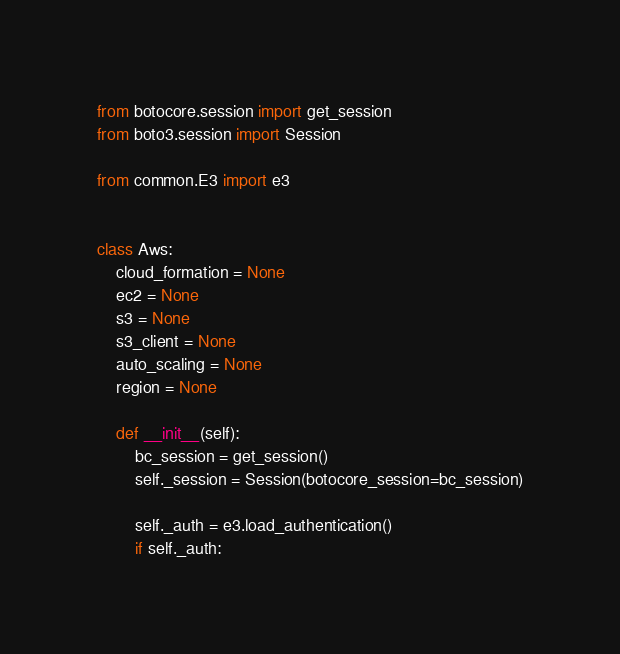Convert code to text. <code><loc_0><loc_0><loc_500><loc_500><_Python_>from botocore.session import get_session
from boto3.session import Session

from common.E3 import e3


class Aws:
    cloud_formation = None
    ec2 = None
    s3 = None
    s3_client = None
    auto_scaling = None
    region = None

    def __init__(self):
        bc_session = get_session()
        self._session = Session(botocore_session=bc_session)

        self._auth = e3.load_authentication()
        if self._auth:</code> 